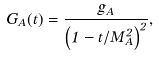Convert formula to latex. <formula><loc_0><loc_0><loc_500><loc_500>G _ { A } ( t ) = \frac { g _ { A } } { \left ( 1 - t / M _ { A } ^ { 2 } \right ) ^ { 2 } } ,</formula> 